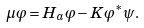<formula> <loc_0><loc_0><loc_500><loc_500>\mu \varphi = H _ { a } \varphi - K \varphi ^ { * } \psi .</formula> 